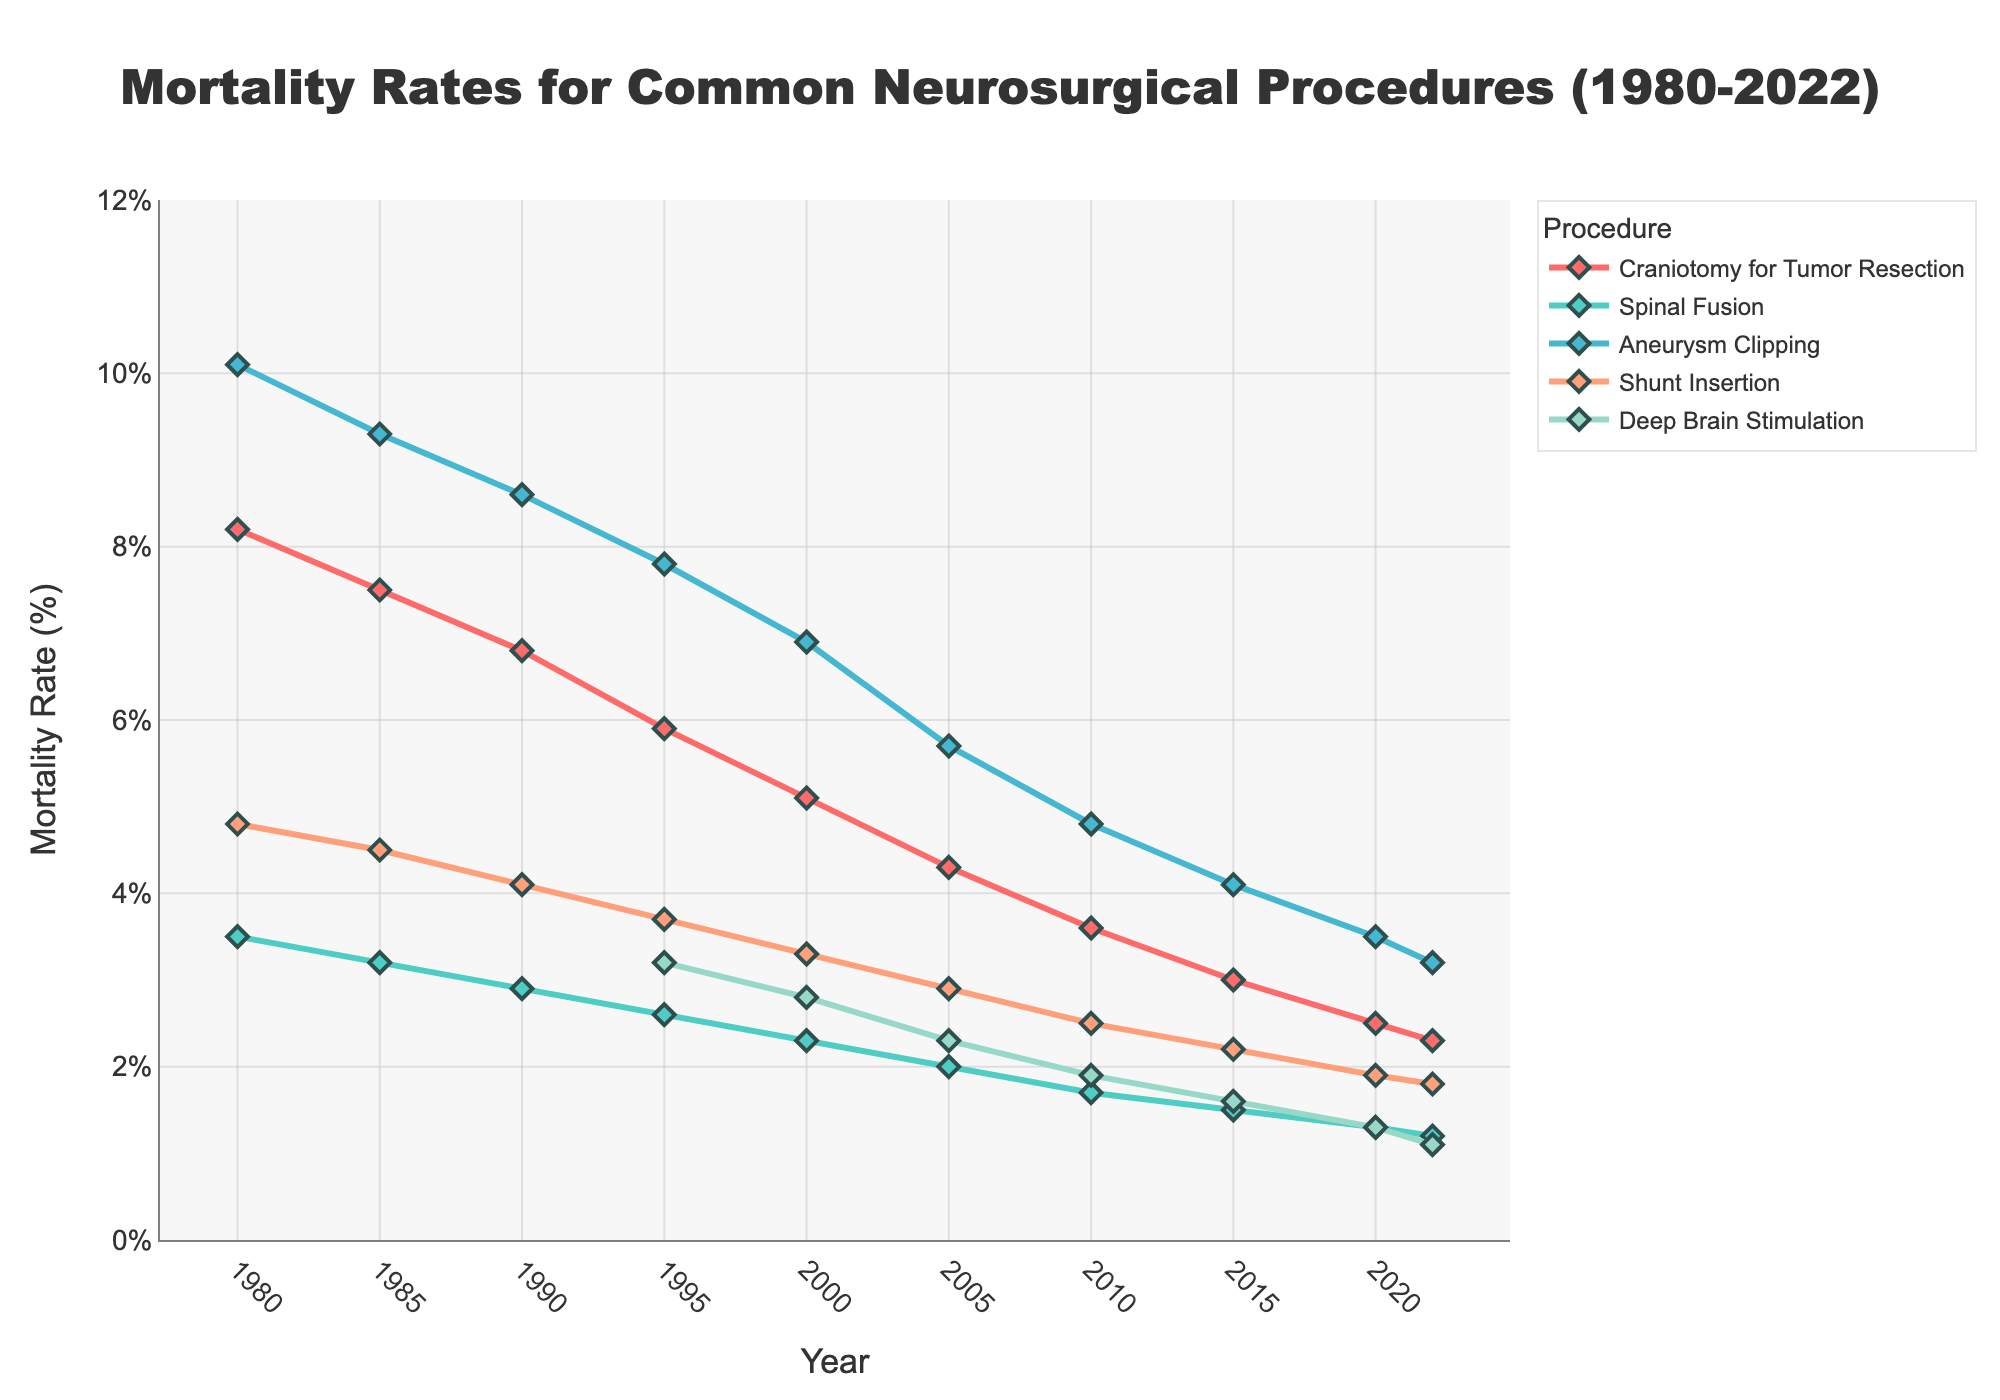What is the trend in the mortality rate for Craniotomy for Tumor Resection from 1980 to 2022? The mortality rate for Craniotomy for Tumor Resection has shown a consistent downward trend over the years. Starting at 8.2% in 1980, it decreases to 2.3% by 2022.
Answer: Downward trend Which procedure had the highest mortality rate in 1980? By examining the mortality rates for all procedures in 1980, Aneurysm Clipping had the highest rate at 10.1%.
Answer: Aneurysm Clipping How did the mortality rate for Shunt Insertion change between 1985 and 2010? From 1985 to 2010, the mortality rate for Shunt Insertion decreased from 4.5% to 2.5%. This shows a reduction by 2 percentage points.
Answer: Decreased by 2% Which neurosurgical procedure saw the most significant decline in mortality rate from 1995 to 2022? Comparing the changes in mortality rates from 1995 to 2022 for all procedures, Craniotomy for Tumor Resection had a drop from 5.9% to 2.3% (a 3.6 percentage points decrease), the largest among all.
Answer: Craniotomy for Tumor Resection In which year did Deep Brain Stimulation have the lowest recorded mortality rate, and what was the rate? Looking at the years for Deep Brain Stimulation data, the lowest recorded rate was in 2022, at 1.1%.
Answer: 2022, 1.1% Between 1980 and 2022, which procedure consistently had the lowest mortality rate? Throughout the years from 1980 to 2022, Spinal Fusion consistently had the lowest mortality rates compared to the other procedures listed.
Answer: Spinal Fusion What is the total change in the mortality rate for Aneurysm Clipping from 1980 to 2022? The mortality rate for Aneurysm Clipping decreased from 10.1% in 1980 to 3.2% in 2022. The total change is 10.1% - 3.2% = 6.9 percentage points.
Answer: 6.9 percentage points How has the mortality rate for Spinal Fusion progressed visually from 1980 to 2022? The mortality rate for Spinal Fusion is represented by a line that starts higher in 1980 at 3.5% and descends progressively to 1.2% by 2022, showing a clear downward trend.
Answer: Downward trend Compare the average mortality rates of Craniotomy for Tumor Resection and Shunt Insertion between 1980 to 2022. Which one is higher? To find the average, sum up the mortality rates for each procedure across all years and divide by the number of years. Craniotomy for Tumor Resection: (8.2 + 7.5 + 6.8 + 5.9 + 5.1 + 4.3 + 3.6 + 3.0 + 2.5 + 2.3)/10 = 4.92%. Shunt Insertion: (4.8 + 4.5 + 4.1 + 3.7 + 3.3 + 2.9 + 2.5 + 2.2 + 1.9 + 1.8)/10 = 3.37%. The average for Craniotomy for Tumor Resection is higher.
Answer: Craniotomy for Tumor Resection 